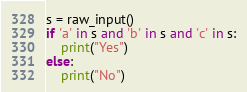<code> <loc_0><loc_0><loc_500><loc_500><_Python_>s = raw_input()
if 'a' in s and 'b' in s and 'c' in s:
    print("Yes")
else:
    print("No")

</code> 